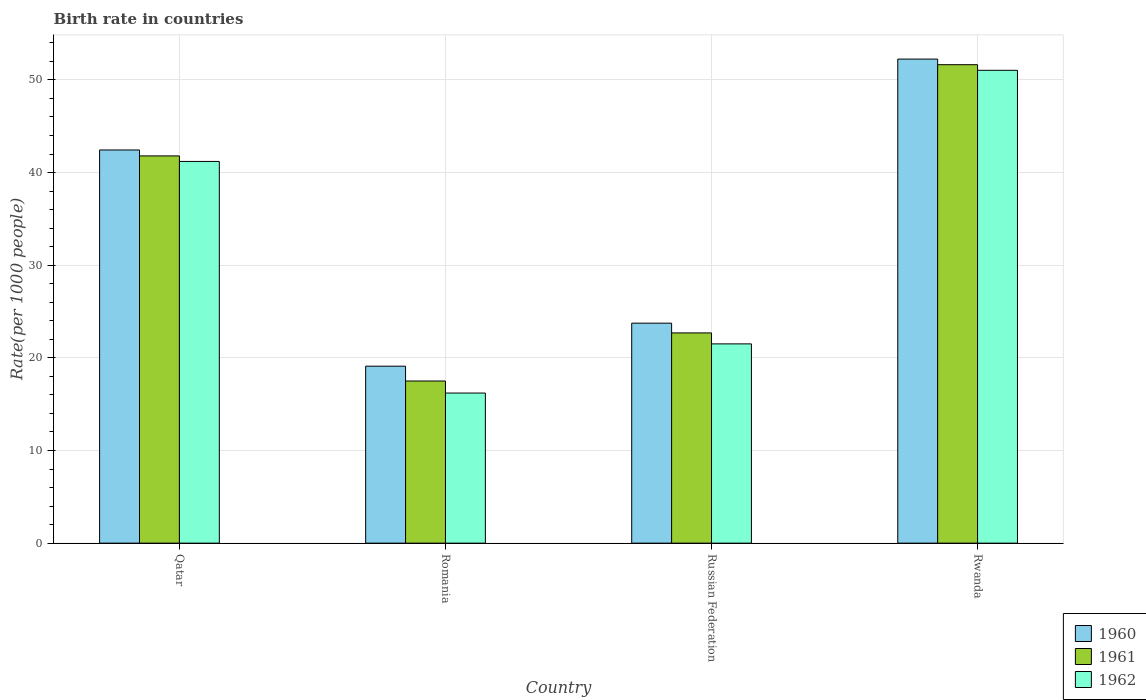How many groups of bars are there?
Make the answer very short. 4. Are the number of bars per tick equal to the number of legend labels?
Provide a short and direct response. Yes. What is the label of the 4th group of bars from the left?
Make the answer very short. Rwanda. What is the birth rate in 1960 in Qatar?
Offer a very short reply. 42.44. Across all countries, what is the maximum birth rate in 1961?
Ensure brevity in your answer.  51.64. Across all countries, what is the minimum birth rate in 1961?
Give a very brief answer. 17.5. In which country was the birth rate in 1962 maximum?
Your response must be concise. Rwanda. In which country was the birth rate in 1962 minimum?
Give a very brief answer. Romania. What is the total birth rate in 1960 in the graph?
Keep it short and to the point. 137.53. What is the difference between the birth rate in 1960 in Qatar and that in Russian Federation?
Your answer should be compact. 18.69. What is the difference between the birth rate in 1961 in Qatar and the birth rate in 1960 in Russian Federation?
Provide a short and direct response. 18.05. What is the average birth rate in 1961 per country?
Give a very brief answer. 33.41. What is the difference between the birth rate of/in 1961 and birth rate of/in 1960 in Russian Federation?
Offer a terse response. -1.05. In how many countries, is the birth rate in 1960 greater than 30?
Make the answer very short. 2. What is the ratio of the birth rate in 1962 in Romania to that in Russian Federation?
Make the answer very short. 0.75. Is the birth rate in 1962 in Romania less than that in Rwanda?
Offer a very short reply. Yes. Is the difference between the birth rate in 1961 in Russian Federation and Rwanda greater than the difference between the birth rate in 1960 in Russian Federation and Rwanda?
Give a very brief answer. No. What is the difference between the highest and the second highest birth rate in 1961?
Your response must be concise. -9.85. What is the difference between the highest and the lowest birth rate in 1961?
Offer a terse response. 34.14. Is it the case that in every country, the sum of the birth rate in 1960 and birth rate in 1961 is greater than the birth rate in 1962?
Offer a very short reply. Yes. How many bars are there?
Ensure brevity in your answer.  12. Are all the bars in the graph horizontal?
Your answer should be very brief. No. How many countries are there in the graph?
Give a very brief answer. 4. Does the graph contain any zero values?
Provide a succinct answer. No. Does the graph contain grids?
Keep it short and to the point. Yes. Where does the legend appear in the graph?
Your answer should be compact. Bottom right. What is the title of the graph?
Provide a short and direct response. Birth rate in countries. What is the label or title of the Y-axis?
Your answer should be compact. Rate(per 1000 people). What is the Rate(per 1000 people) in 1960 in Qatar?
Make the answer very short. 42.44. What is the Rate(per 1000 people) in 1961 in Qatar?
Keep it short and to the point. 41.8. What is the Rate(per 1000 people) in 1962 in Qatar?
Your response must be concise. 41.2. What is the Rate(per 1000 people) in 1960 in Russian Federation?
Your answer should be very brief. 23.74. What is the Rate(per 1000 people) of 1961 in Russian Federation?
Keep it short and to the point. 22.69. What is the Rate(per 1000 people) in 1962 in Russian Federation?
Provide a short and direct response. 21.51. What is the Rate(per 1000 people) in 1960 in Rwanda?
Keep it short and to the point. 52.25. What is the Rate(per 1000 people) in 1961 in Rwanda?
Give a very brief answer. 51.64. What is the Rate(per 1000 people) in 1962 in Rwanda?
Keep it short and to the point. 51.04. Across all countries, what is the maximum Rate(per 1000 people) of 1960?
Your response must be concise. 52.25. Across all countries, what is the maximum Rate(per 1000 people) of 1961?
Your answer should be very brief. 51.64. Across all countries, what is the maximum Rate(per 1000 people) in 1962?
Make the answer very short. 51.04. Across all countries, what is the minimum Rate(per 1000 people) in 1960?
Ensure brevity in your answer.  19.1. Across all countries, what is the minimum Rate(per 1000 people) of 1962?
Ensure brevity in your answer.  16.2. What is the total Rate(per 1000 people) of 1960 in the graph?
Make the answer very short. 137.53. What is the total Rate(per 1000 people) in 1961 in the graph?
Your answer should be compact. 133.63. What is the total Rate(per 1000 people) of 1962 in the graph?
Provide a short and direct response. 129.94. What is the difference between the Rate(per 1000 people) in 1960 in Qatar and that in Romania?
Offer a terse response. 23.34. What is the difference between the Rate(per 1000 people) of 1961 in Qatar and that in Romania?
Your answer should be very brief. 24.3. What is the difference between the Rate(per 1000 people) of 1960 in Qatar and that in Russian Federation?
Offer a terse response. 18.69. What is the difference between the Rate(per 1000 people) of 1961 in Qatar and that in Russian Federation?
Provide a succinct answer. 19.1. What is the difference between the Rate(per 1000 people) of 1962 in Qatar and that in Russian Federation?
Provide a succinct answer. 19.69. What is the difference between the Rate(per 1000 people) in 1960 in Qatar and that in Rwanda?
Your answer should be very brief. -9.81. What is the difference between the Rate(per 1000 people) of 1961 in Qatar and that in Rwanda?
Offer a very short reply. -9.85. What is the difference between the Rate(per 1000 people) in 1962 in Qatar and that in Rwanda?
Make the answer very short. -9.84. What is the difference between the Rate(per 1000 people) in 1960 in Romania and that in Russian Federation?
Give a very brief answer. -4.64. What is the difference between the Rate(per 1000 people) of 1961 in Romania and that in Russian Federation?
Offer a terse response. -5.19. What is the difference between the Rate(per 1000 people) of 1962 in Romania and that in Russian Federation?
Your answer should be compact. -5.31. What is the difference between the Rate(per 1000 people) of 1960 in Romania and that in Rwanda?
Give a very brief answer. -33.15. What is the difference between the Rate(per 1000 people) of 1961 in Romania and that in Rwanda?
Offer a terse response. -34.14. What is the difference between the Rate(per 1000 people) in 1962 in Romania and that in Rwanda?
Your answer should be compact. -34.84. What is the difference between the Rate(per 1000 people) of 1960 in Russian Federation and that in Rwanda?
Provide a succinct answer. -28.5. What is the difference between the Rate(per 1000 people) of 1961 in Russian Federation and that in Rwanda?
Ensure brevity in your answer.  -28.95. What is the difference between the Rate(per 1000 people) of 1962 in Russian Federation and that in Rwanda?
Offer a very short reply. -29.53. What is the difference between the Rate(per 1000 people) in 1960 in Qatar and the Rate(per 1000 people) in 1961 in Romania?
Offer a very short reply. 24.94. What is the difference between the Rate(per 1000 people) of 1960 in Qatar and the Rate(per 1000 people) of 1962 in Romania?
Keep it short and to the point. 26.24. What is the difference between the Rate(per 1000 people) of 1961 in Qatar and the Rate(per 1000 people) of 1962 in Romania?
Ensure brevity in your answer.  25.6. What is the difference between the Rate(per 1000 people) in 1960 in Qatar and the Rate(per 1000 people) in 1961 in Russian Federation?
Offer a terse response. 19.74. What is the difference between the Rate(per 1000 people) of 1960 in Qatar and the Rate(per 1000 people) of 1962 in Russian Federation?
Provide a succinct answer. 20.93. What is the difference between the Rate(per 1000 people) of 1961 in Qatar and the Rate(per 1000 people) of 1962 in Russian Federation?
Provide a short and direct response. 20.29. What is the difference between the Rate(per 1000 people) of 1960 in Qatar and the Rate(per 1000 people) of 1961 in Rwanda?
Provide a short and direct response. -9.21. What is the difference between the Rate(per 1000 people) of 1961 in Qatar and the Rate(per 1000 people) of 1962 in Rwanda?
Offer a very short reply. -9.24. What is the difference between the Rate(per 1000 people) in 1960 in Romania and the Rate(per 1000 people) in 1961 in Russian Federation?
Keep it short and to the point. -3.59. What is the difference between the Rate(per 1000 people) in 1960 in Romania and the Rate(per 1000 people) in 1962 in Russian Federation?
Your response must be concise. -2.41. What is the difference between the Rate(per 1000 people) of 1961 in Romania and the Rate(per 1000 people) of 1962 in Russian Federation?
Give a very brief answer. -4.01. What is the difference between the Rate(per 1000 people) of 1960 in Romania and the Rate(per 1000 people) of 1961 in Rwanda?
Give a very brief answer. -32.54. What is the difference between the Rate(per 1000 people) of 1960 in Romania and the Rate(per 1000 people) of 1962 in Rwanda?
Make the answer very short. -31.94. What is the difference between the Rate(per 1000 people) of 1961 in Romania and the Rate(per 1000 people) of 1962 in Rwanda?
Your answer should be very brief. -33.54. What is the difference between the Rate(per 1000 people) of 1960 in Russian Federation and the Rate(per 1000 people) of 1961 in Rwanda?
Offer a very short reply. -27.9. What is the difference between the Rate(per 1000 people) in 1960 in Russian Federation and the Rate(per 1000 people) in 1962 in Rwanda?
Ensure brevity in your answer.  -27.29. What is the difference between the Rate(per 1000 people) of 1961 in Russian Federation and the Rate(per 1000 people) of 1962 in Rwanda?
Offer a very short reply. -28.34. What is the average Rate(per 1000 people) in 1960 per country?
Offer a terse response. 34.38. What is the average Rate(per 1000 people) of 1961 per country?
Make the answer very short. 33.41. What is the average Rate(per 1000 people) in 1962 per country?
Ensure brevity in your answer.  32.49. What is the difference between the Rate(per 1000 people) in 1960 and Rate(per 1000 people) in 1961 in Qatar?
Offer a terse response. 0.64. What is the difference between the Rate(per 1000 people) of 1960 and Rate(per 1000 people) of 1962 in Qatar?
Give a very brief answer. 1.24. What is the difference between the Rate(per 1000 people) in 1961 and Rate(per 1000 people) in 1962 in Qatar?
Provide a short and direct response. 0.6. What is the difference between the Rate(per 1000 people) in 1960 and Rate(per 1000 people) in 1961 in Romania?
Offer a terse response. 1.6. What is the difference between the Rate(per 1000 people) in 1961 and Rate(per 1000 people) in 1962 in Romania?
Your answer should be very brief. 1.3. What is the difference between the Rate(per 1000 people) of 1960 and Rate(per 1000 people) of 1961 in Russian Federation?
Ensure brevity in your answer.  1.05. What is the difference between the Rate(per 1000 people) in 1960 and Rate(per 1000 people) in 1962 in Russian Federation?
Give a very brief answer. 2.24. What is the difference between the Rate(per 1000 people) in 1961 and Rate(per 1000 people) in 1962 in Russian Federation?
Keep it short and to the point. 1.19. What is the difference between the Rate(per 1000 people) of 1960 and Rate(per 1000 people) of 1961 in Rwanda?
Offer a very short reply. 0.61. What is the difference between the Rate(per 1000 people) in 1960 and Rate(per 1000 people) in 1962 in Rwanda?
Offer a terse response. 1.21. What is the difference between the Rate(per 1000 people) of 1961 and Rate(per 1000 people) of 1962 in Rwanda?
Ensure brevity in your answer.  0.61. What is the ratio of the Rate(per 1000 people) of 1960 in Qatar to that in Romania?
Your answer should be compact. 2.22. What is the ratio of the Rate(per 1000 people) in 1961 in Qatar to that in Romania?
Offer a very short reply. 2.39. What is the ratio of the Rate(per 1000 people) of 1962 in Qatar to that in Romania?
Your response must be concise. 2.54. What is the ratio of the Rate(per 1000 people) of 1960 in Qatar to that in Russian Federation?
Offer a terse response. 1.79. What is the ratio of the Rate(per 1000 people) in 1961 in Qatar to that in Russian Federation?
Provide a succinct answer. 1.84. What is the ratio of the Rate(per 1000 people) in 1962 in Qatar to that in Russian Federation?
Give a very brief answer. 1.92. What is the ratio of the Rate(per 1000 people) of 1960 in Qatar to that in Rwanda?
Ensure brevity in your answer.  0.81. What is the ratio of the Rate(per 1000 people) in 1961 in Qatar to that in Rwanda?
Offer a terse response. 0.81. What is the ratio of the Rate(per 1000 people) of 1962 in Qatar to that in Rwanda?
Keep it short and to the point. 0.81. What is the ratio of the Rate(per 1000 people) in 1960 in Romania to that in Russian Federation?
Provide a succinct answer. 0.8. What is the ratio of the Rate(per 1000 people) of 1961 in Romania to that in Russian Federation?
Make the answer very short. 0.77. What is the ratio of the Rate(per 1000 people) of 1962 in Romania to that in Russian Federation?
Your response must be concise. 0.75. What is the ratio of the Rate(per 1000 people) of 1960 in Romania to that in Rwanda?
Give a very brief answer. 0.37. What is the ratio of the Rate(per 1000 people) of 1961 in Romania to that in Rwanda?
Provide a succinct answer. 0.34. What is the ratio of the Rate(per 1000 people) in 1962 in Romania to that in Rwanda?
Offer a terse response. 0.32. What is the ratio of the Rate(per 1000 people) in 1960 in Russian Federation to that in Rwanda?
Your response must be concise. 0.45. What is the ratio of the Rate(per 1000 people) in 1961 in Russian Federation to that in Rwanda?
Provide a short and direct response. 0.44. What is the ratio of the Rate(per 1000 people) of 1962 in Russian Federation to that in Rwanda?
Give a very brief answer. 0.42. What is the difference between the highest and the second highest Rate(per 1000 people) in 1960?
Ensure brevity in your answer.  9.81. What is the difference between the highest and the second highest Rate(per 1000 people) in 1961?
Provide a succinct answer. 9.85. What is the difference between the highest and the second highest Rate(per 1000 people) in 1962?
Provide a succinct answer. 9.84. What is the difference between the highest and the lowest Rate(per 1000 people) of 1960?
Your response must be concise. 33.15. What is the difference between the highest and the lowest Rate(per 1000 people) in 1961?
Provide a succinct answer. 34.14. What is the difference between the highest and the lowest Rate(per 1000 people) of 1962?
Ensure brevity in your answer.  34.84. 